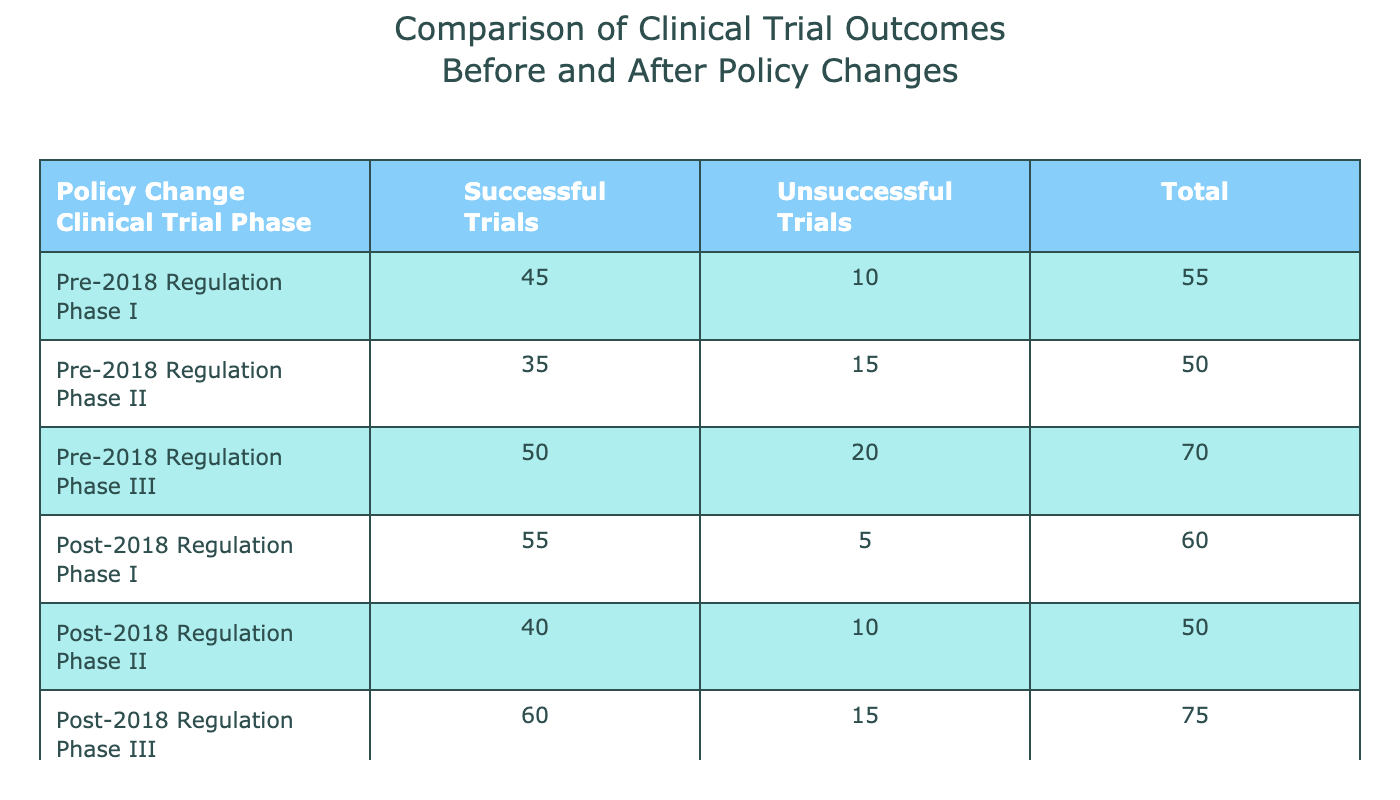What is the total number of successful trials in Phase I before the 2018 regulation? The table indicates that for Phase I under the pre-2018 regulation, the number of successful trials is 45.
Answer: 45 How many unsuccessful trials occurred in Phase II after the 2018 regulation? The table shows that in Phase II after the post-2018 regulation, the count of unsuccessful trials is 10.
Answer: 10 What is the difference in the number of successful trials between the pre-2018 and post-2018 regulations in Phase III? In the table, the successful trials for Phase III before the 2018 regulation is 50 and after is 60. The difference is 60 - 50 = 10.
Answer: 10 What is the average number of unsuccessful trials across all phases after the 2018 regulation? The unsuccessful trials for each phase are: Phase I (5), Phase II (10), and Phase III (15). Summing them gives 5 + 10 + 15 = 30. There are 3 phases, so the average is 30 / 3 = 10.
Answer: 10 Did the number of successful trials increase across all phases after the 2018 regulation compared to before? By examining the table: Phase I (45 to 55), Phase II (35 to 40), and Phase III (50 to 60) all show an increase. Thus, yes, successful trials increased in every phase.
Answer: Yes What is the total number of trials (successful + unsuccessful) in Phase II before the 2018 regulation? For Phase II under the pre-2018 regulation, there were 35 successful trials and 15 unsuccessful trials. The total is 35 + 15 = 50.
Answer: 50 Which phase experienced the largest increase in successful trials after the policy change? The gains in successful trials were: Phase I (55 - 45 = 10), Phase II (40 - 35 = 5), and Phase III (60 - 50 = 10). Both Phase I and Phase III had the largest increase of 10.
Answer: Phase I and Phase III Is it true that the number of successful trials in Phase II was greater than those in Phase III before the 2018 regulation? Looking at the table, Phase II had 35 successful trials and Phase III had 50. Since 35 is less than 50, the statement is false.
Answer: No What are the unsuccessful trial totals for all phases combined after the 2018 regulation? The unsuccessful trials after the regulation are: Phase I (5), Phase II (10), and Phase III (15). Summing these gives 5 + 10 + 15 = 30.
Answer: 30 